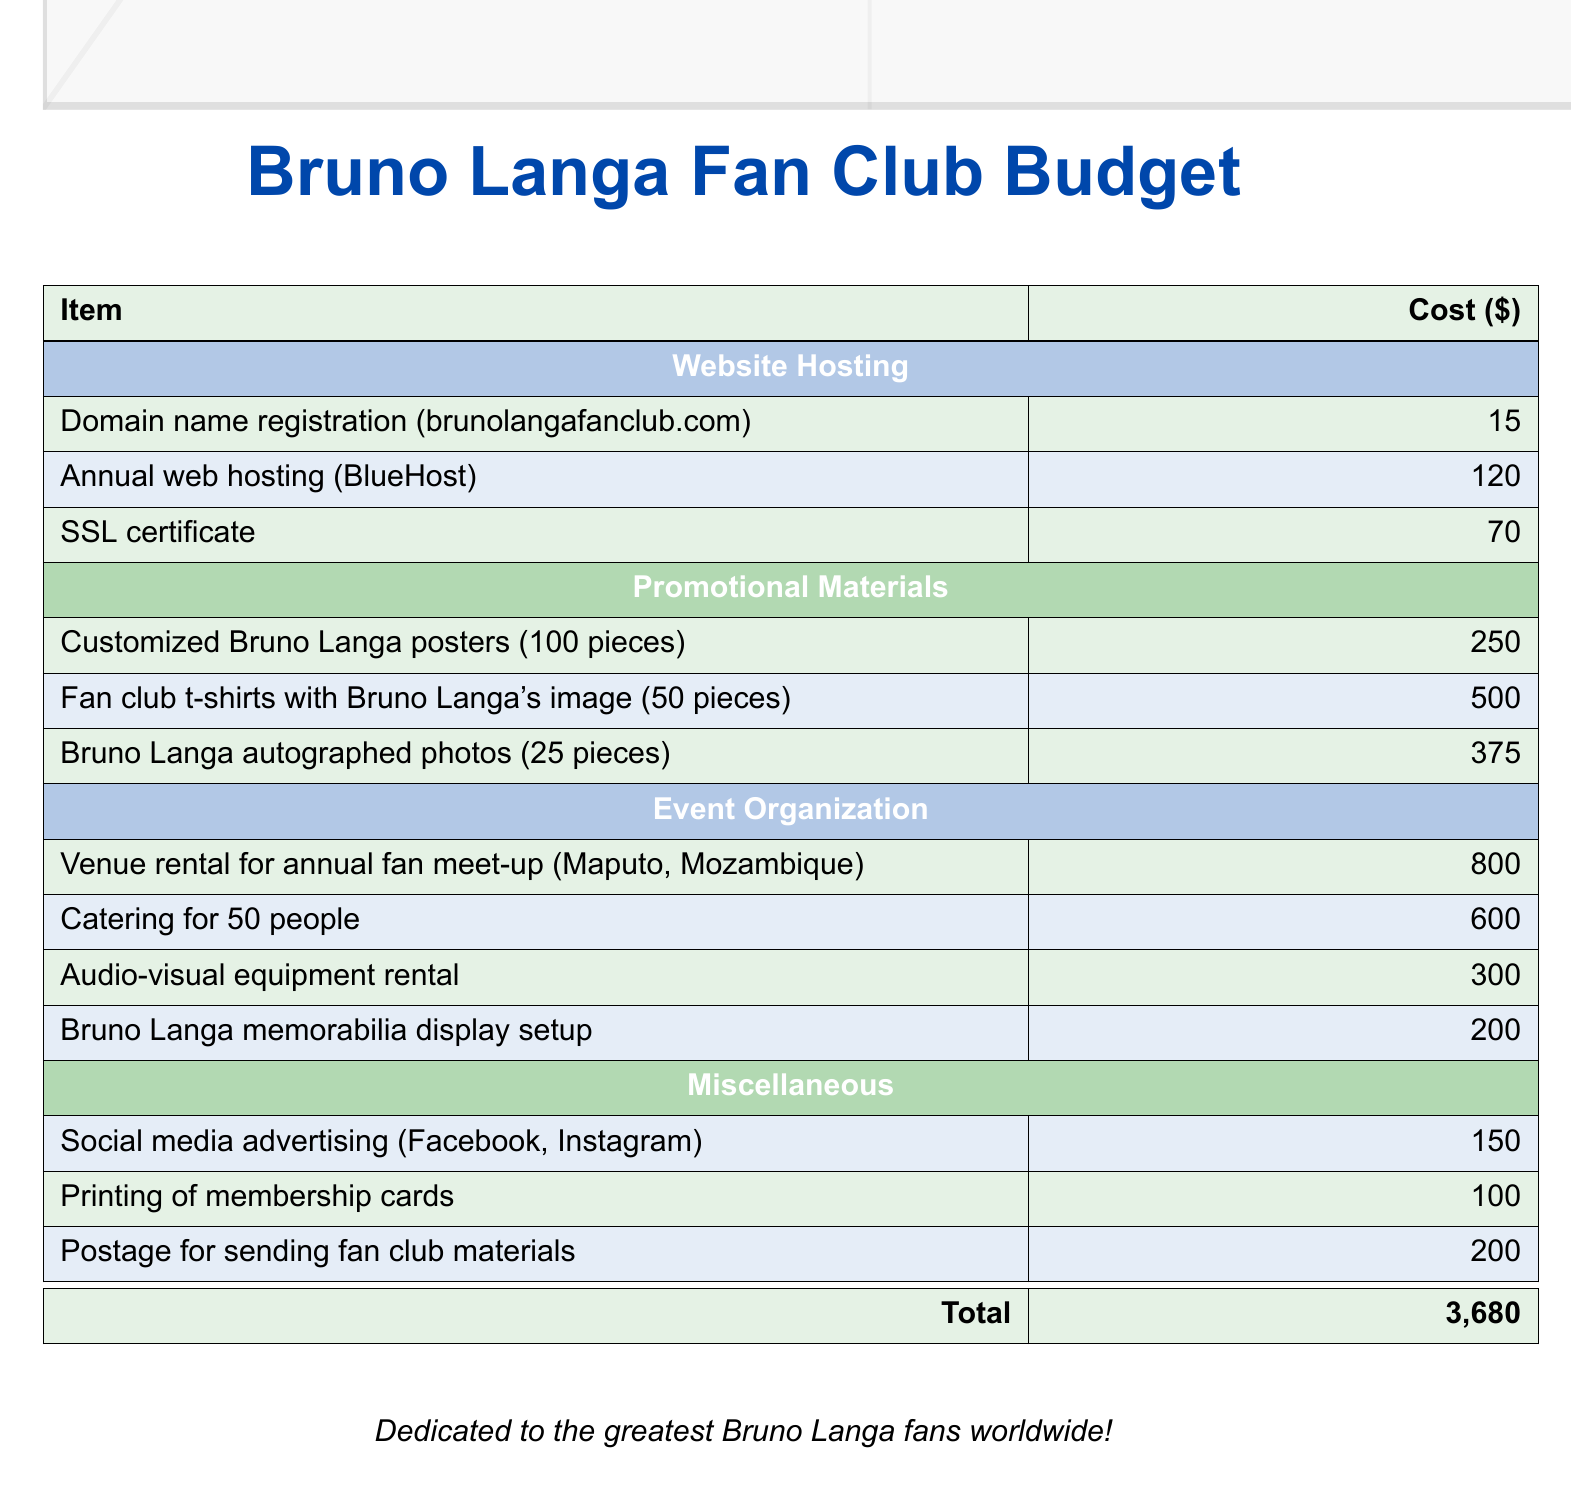what is the cost of the domain name registration? The cost is specified in the website hosting section of the budget document.
Answer: 15 how much is the annual web hosting fee? The annual web hosting fee is outlined in the budget document under website hosting.
Answer: 120 what is the total cost of promotional materials? The total cost can be calculated by adding the costs of all promotional materials listed in the document.
Answer: 1,125 how much does it cost to rent the venue for the annual fan meet-up? The venue rental cost is noted specifically in the event organization section of the budget.
Answer: 800 what is the cost for printing membership cards? The printing cost for membership cards is listed under miscellaneous expenses.
Answer: 100 how much is allocated for social media advertising? The amount for social media advertising is detailed in the miscellaneous section.
Answer: 150 what is the total budget for the Bruno Langa fan club? The total budget is provided as the sum of all costs listed throughout the document.
Answer: 3,680 how many customized Bruno Langa posters are planned to be produced? The number of posters is mentioned in the promotional materials section.
Answer: 100 what expenses are included in the event organization category? The specific expenses can be found listed under the event organization section in the document.
Answer: Venue rental, catering, audio-visual equipment, memorabilia display setup 